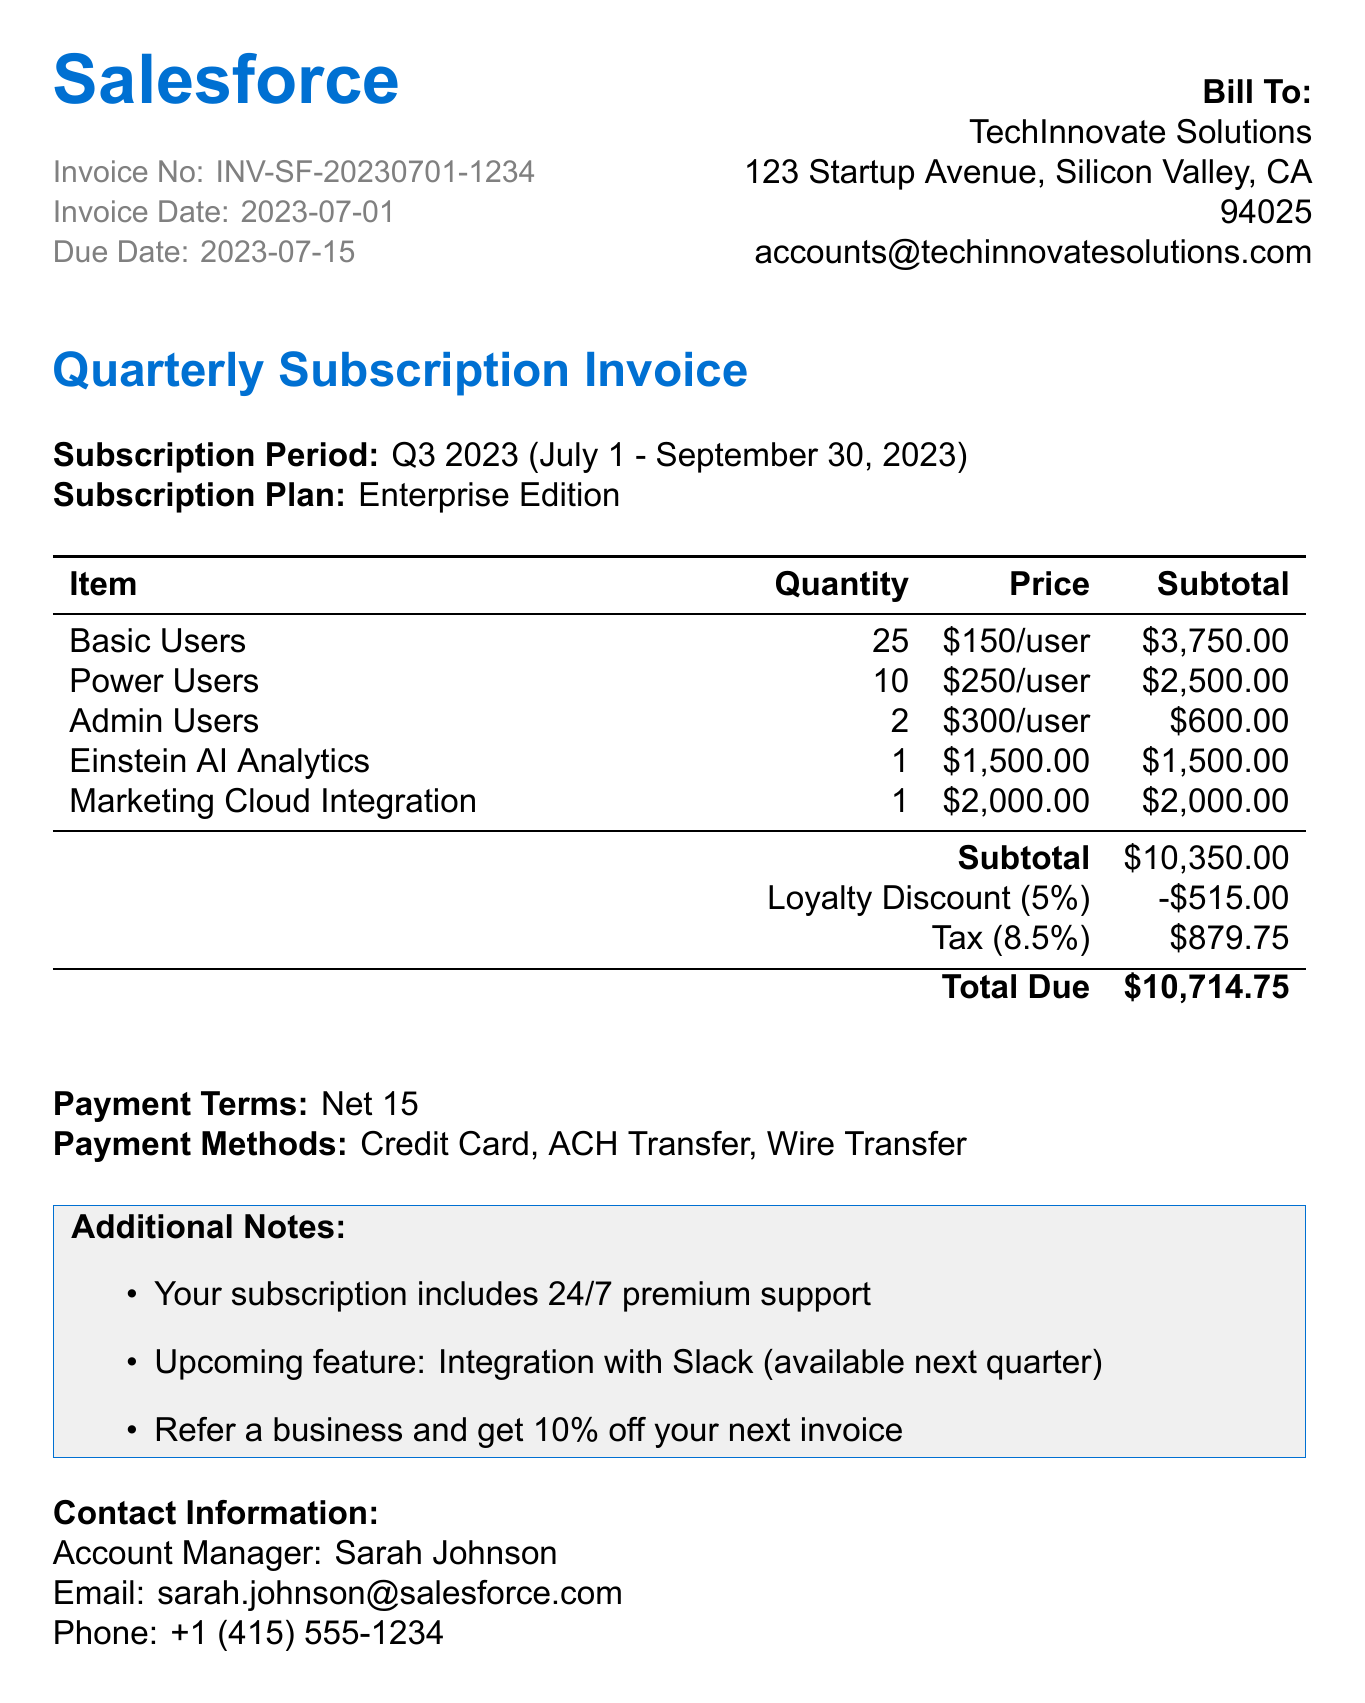what is the invoice number? The invoice number is explicitly listed in the document.
Answer: INV-SF-20230701-1234 what is the due date? The due date is clearly stated in the invoice details.
Answer: 2023-07-15 how many Basic Users are included? The number of Basic Users is provided in the tiered pricing section.
Answer: 25 what is the subtotal before discounts and tax? The subtotal is the sum of all the services before applying any discounts or tax.
Answer: $10,350.00 what is the Loyalty Discount amount? The document specifies the Loyalty Discount amount directly.
Answer: $515.00 what is the tax rate applied to the invoice? The tax rate for the invoice is mentioned in the document.
Answer: 8.5% who is the account manager? The account manager's name is explicitly given in the contact information section.
Answer: Sarah Johnson what are the payment methods available? The available payment methods are mentioned in the payment terms section.
Answer: Credit Card, ACH Transfer, Wire Transfer what is the total amount due on the invoice? The total amount due is calculated and presented at the end of the invoice.
Answer: $10,714.75 what subscription plan is mentioned in the document? The subscription plan is clearly stated in the subscription details section.
Answer: Enterprise Edition 